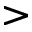<formula> <loc_0><loc_0><loc_500><loc_500>></formula> 